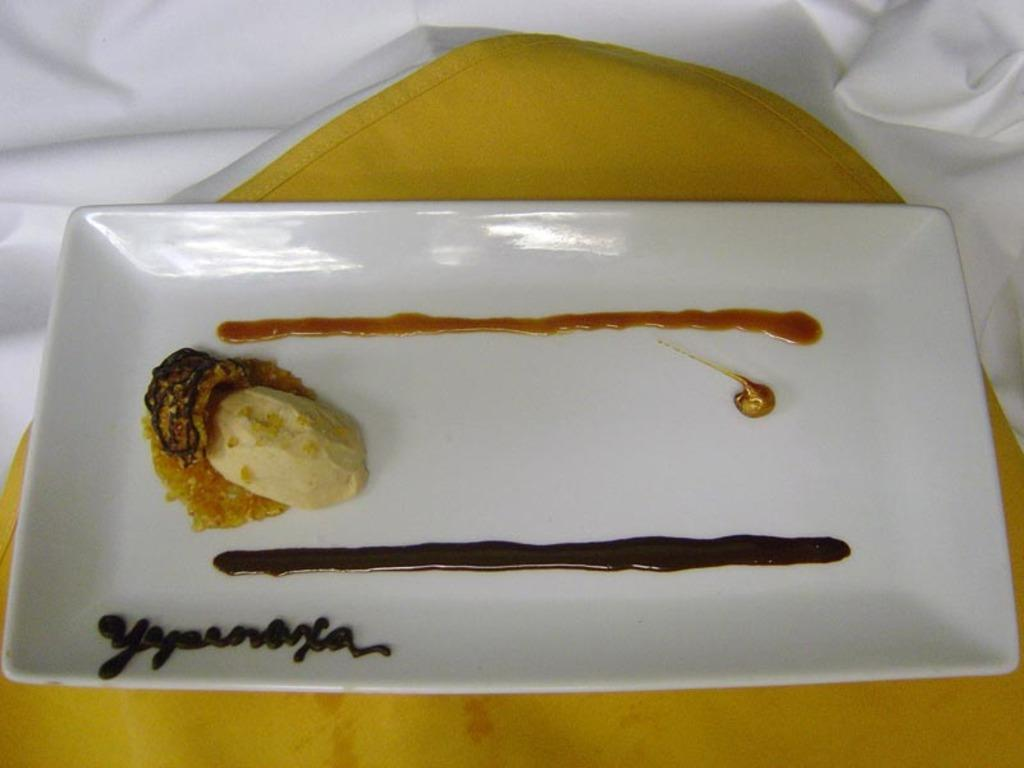What color is the cloth in the image? The cloth in the image is yellow. What is placed on the yellow cloth? There is a white plate on the yellow cloth. What is in the white plate? There is food in the white plate. What is written on the plate using cream? Something is written with cream on the plate. Can you see any pets participating in a protest in the image? There are no pets or protests present in the image. 